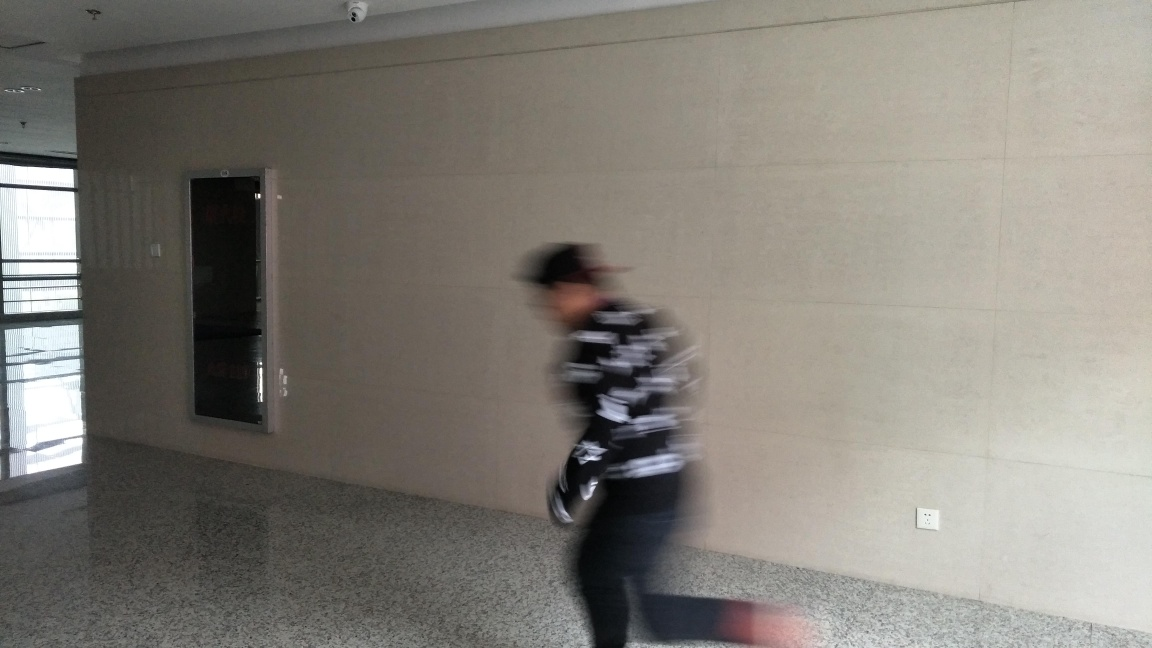Can you describe the style or design of this indoor space? The indoor space appears to have a modern and minimalistic design, with a neutral color palette primarily consisting of beige walls and a speckled gray floor. There's a large, reflective surface on the wall that could be a mirror or a framed decoration, which contributes to the simple, yet functional aesthetic of the environment. 